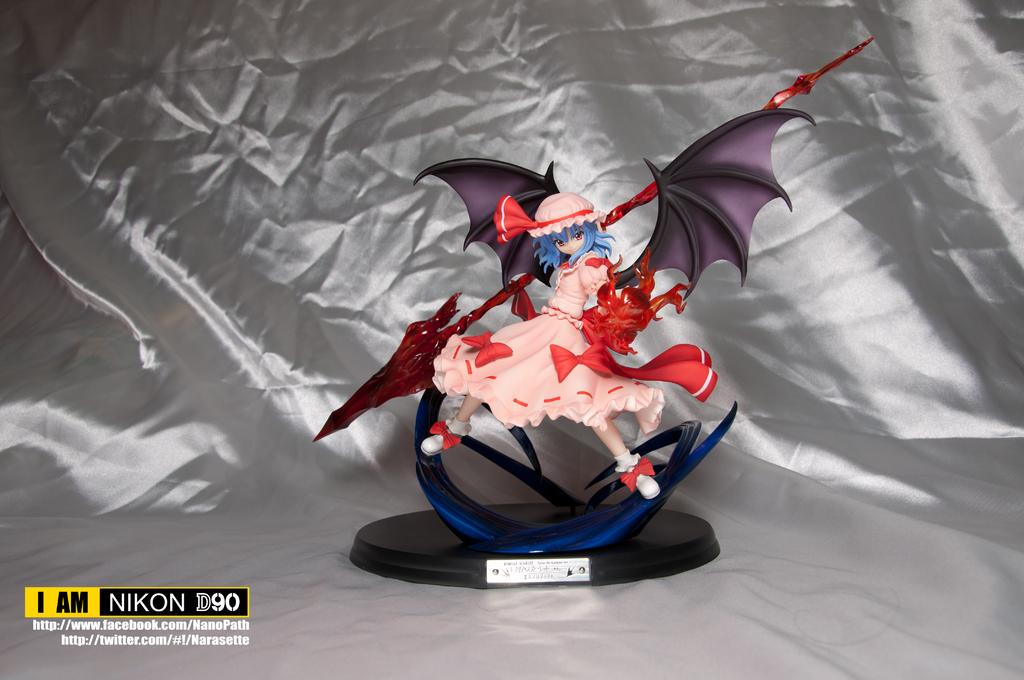What object is present in the image? There is a toy in the image. What is the toy placed on? The toy is on a silver color cloth. Are there any visible marks on the image? Yes, there are watermarks in the image. What type of stew is being prepared on the silver color cloth in the image? There is no stew present in the image; it features a toy on a silver color cloth. Can you tell me how many threads are visible on the toy in the image? The provided facts do not mention the number of threads on the toy, so it cannot be determined from the image. 